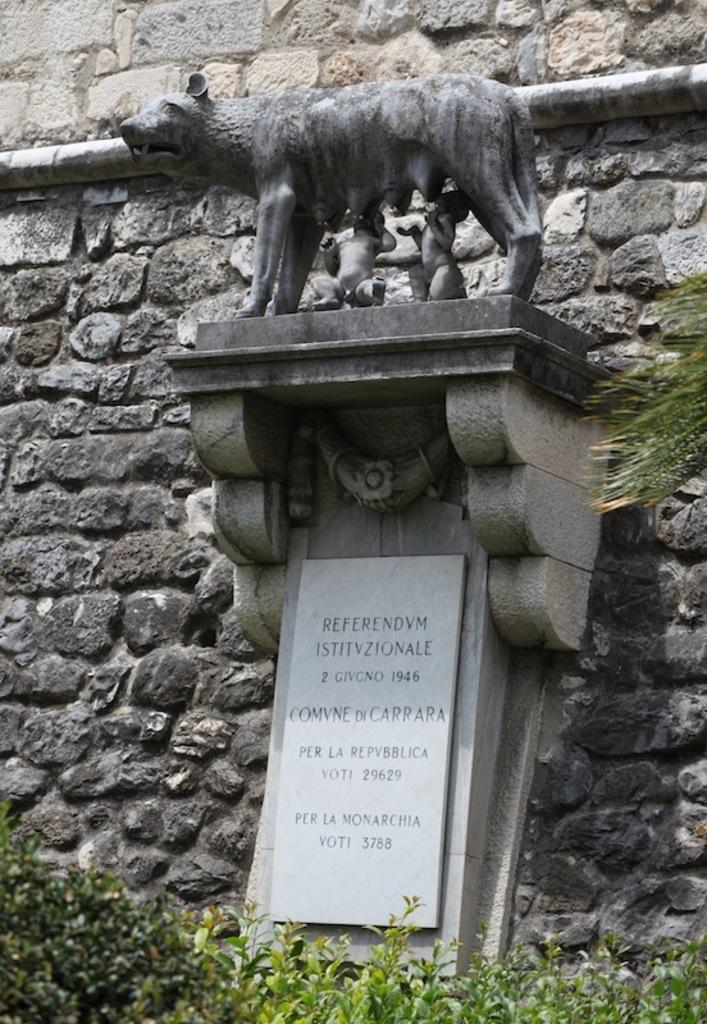What can be seen in the image that represents people or figures? There are statues in the image. What are the statues placed on? The statues are on an object. What is the purpose of the headstone in the image? There is a headstone in the image, which is typically used to mark a grave. What type of vegetation is present in front of the headstone? There are plants in front of the headstone. What natural element is also present in front of the headstone? There is a tree in front of the headstone. What can be seen behind the statues? There is a wall behind the statues. Are there any cherries growing on the tree in the image? There is no mention of cherries or any fruit-bearing trees in the image. Can you identify the actor who created the statues in the image? The image does not provide information about the creator of the statues, nor does it mention any actors. 